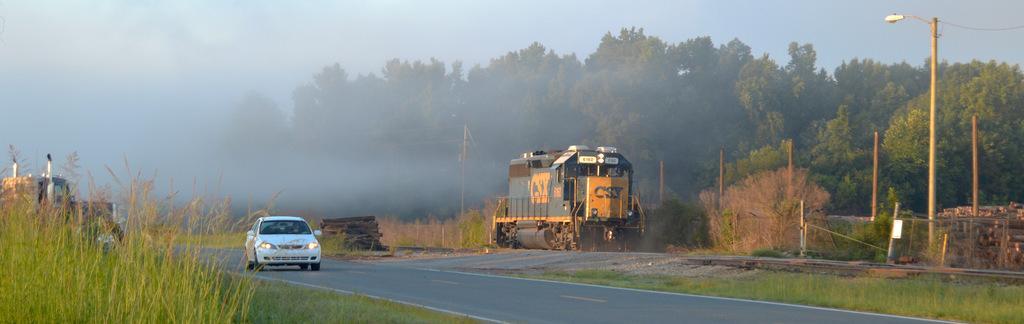Can you describe this image briefly? In this image we can see the vehicles passing on the road. We can also see a train, fence, light pole, some roads, trees and also the grass. We can also see an electric pole with the wires. We can see the wooden sticks, fog and also the sky. 